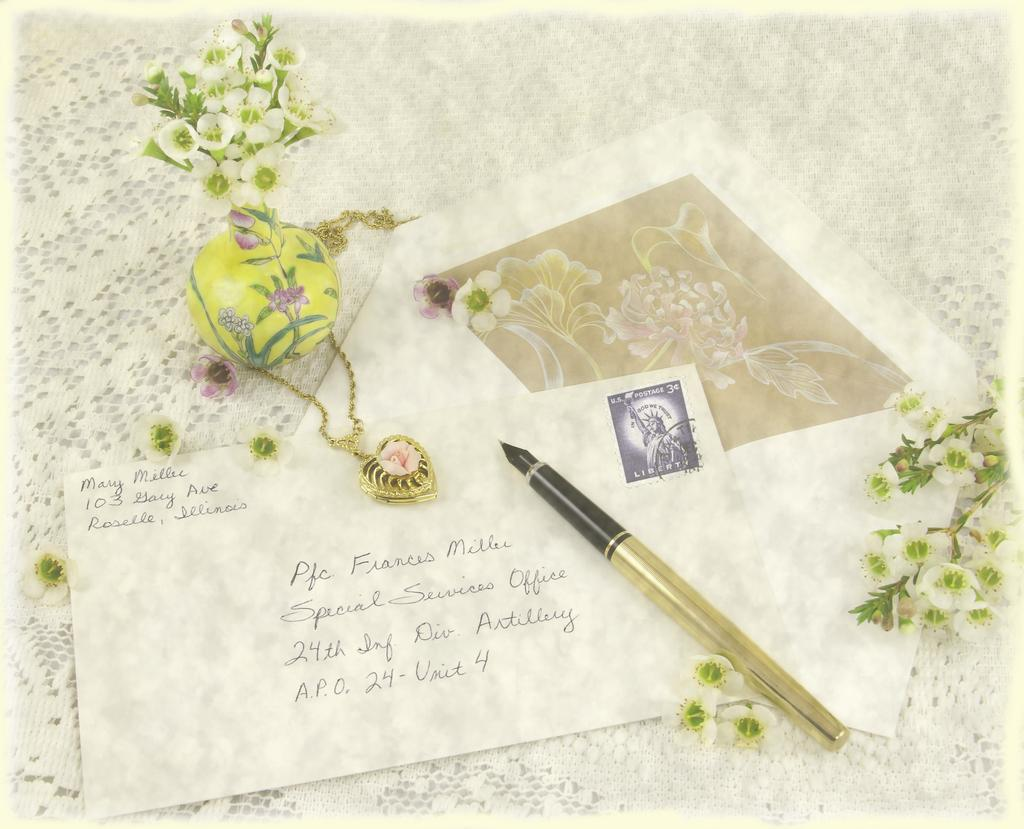<image>
Share a concise interpretation of the image provided. A letter is being written and it is addressed to Frances Miller in the Special Services Office. 